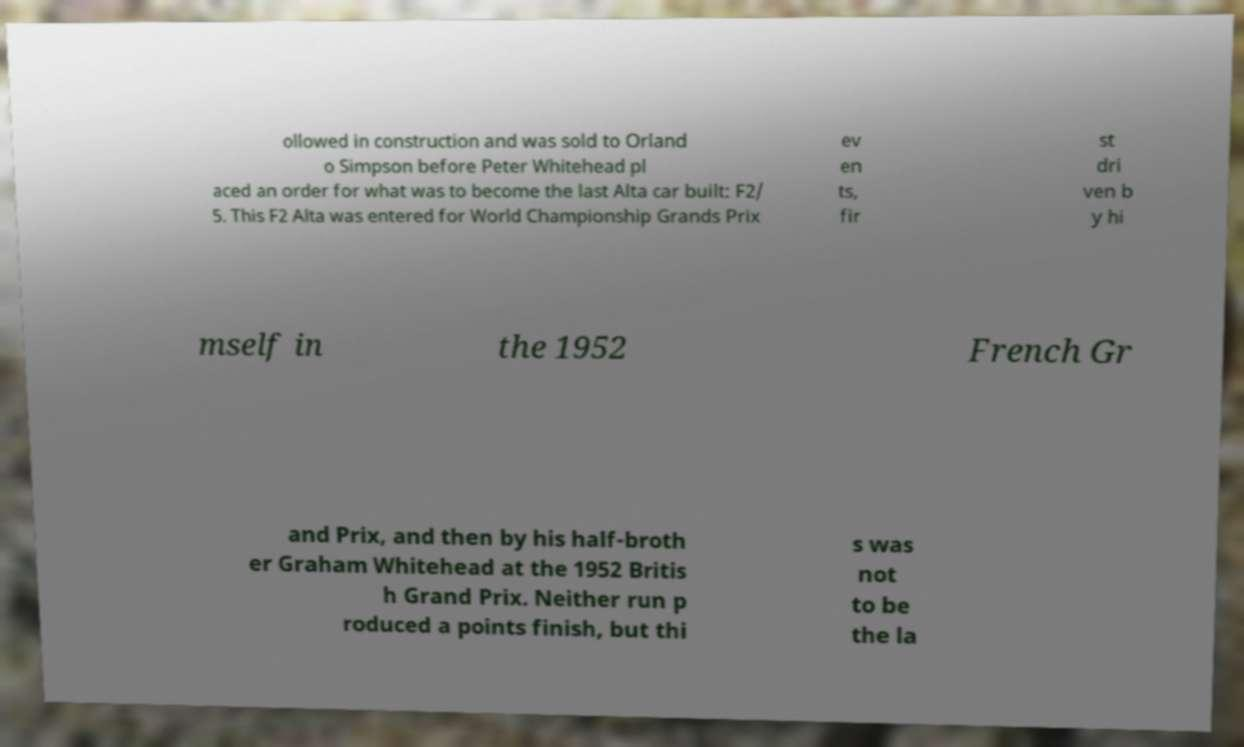For documentation purposes, I need the text within this image transcribed. Could you provide that? ollowed in construction and was sold to Orland o Simpson before Peter Whitehead pl aced an order for what was to become the last Alta car built: F2/ 5. This F2 Alta was entered for World Championship Grands Prix ev en ts, fir st dri ven b y hi mself in the 1952 French Gr and Prix, and then by his half-broth er Graham Whitehead at the 1952 Britis h Grand Prix. Neither run p roduced a points finish, but thi s was not to be the la 